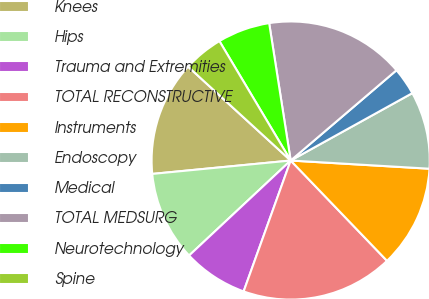Convert chart to OTSL. <chart><loc_0><loc_0><loc_500><loc_500><pie_chart><fcel>Knees<fcel>Hips<fcel>Trauma and Extremities<fcel>TOTAL RECONSTRUCTIVE<fcel>Instruments<fcel>Endoscopy<fcel>Medical<fcel>TOTAL MEDSURG<fcel>Neurotechnology<fcel>Spine<nl><fcel>13.33%<fcel>10.43%<fcel>7.54%<fcel>17.67%<fcel>11.88%<fcel>8.99%<fcel>3.19%<fcel>16.23%<fcel>6.09%<fcel>4.64%<nl></chart> 